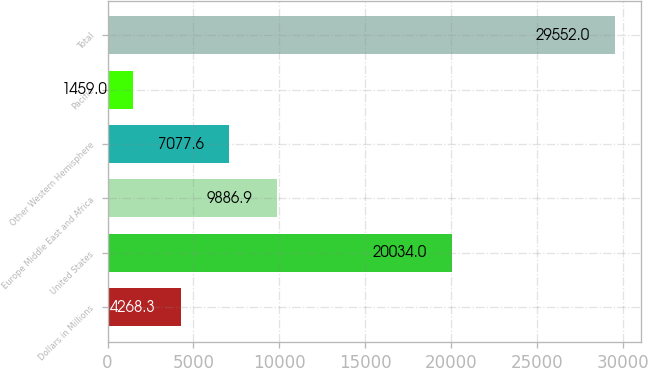Convert chart to OTSL. <chart><loc_0><loc_0><loc_500><loc_500><bar_chart><fcel>Dollars in Millions<fcel>United States<fcel>Europe Middle East and Africa<fcel>Other Western Hemisphere<fcel>Pacific<fcel>Total<nl><fcel>4268.3<fcel>20034<fcel>9886.9<fcel>7077.6<fcel>1459<fcel>29552<nl></chart> 